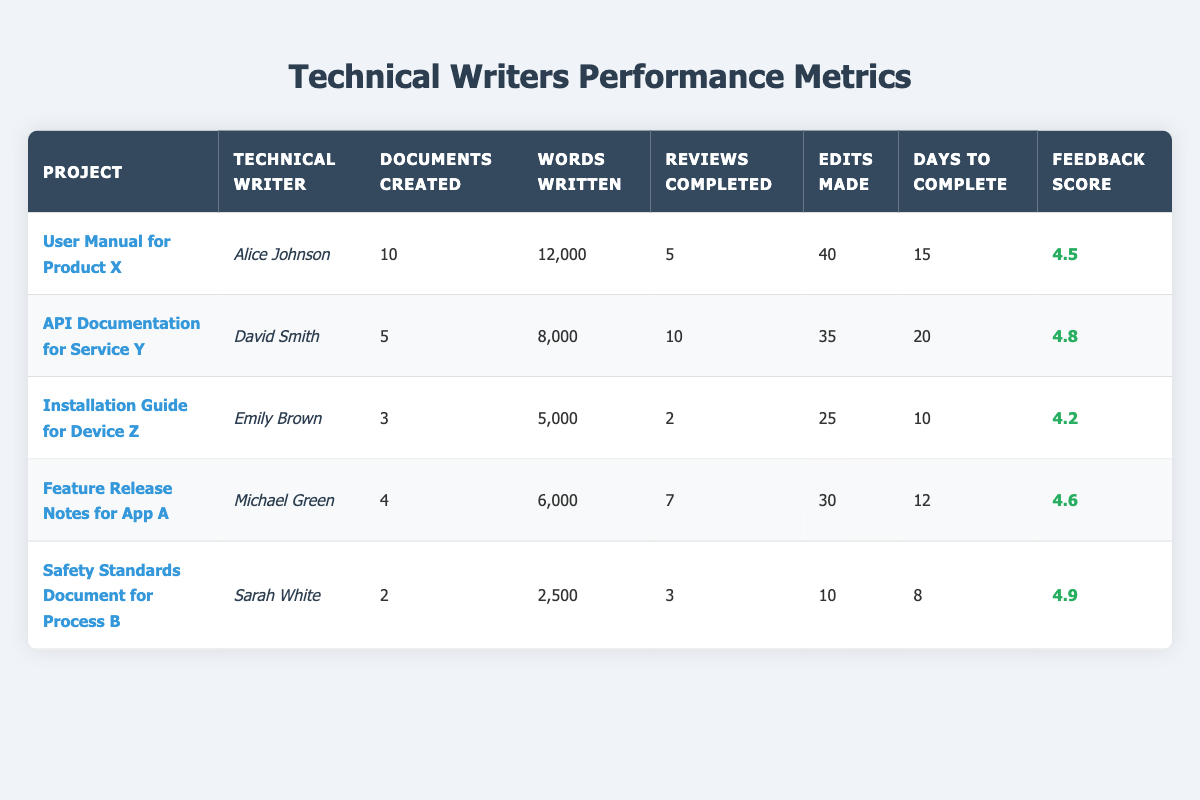What is the feedback score for Alice Johnson's project? The feedback score for Alice Johnson's project, "User Manual for Product X," can be found in the last column for that row. It is listed as 4.5.
Answer: 4.5 Which technical writer created the most documents? To determine which technical writer created the most documents, I look at the "Documents Created" column. Alice Johnson created 10 documents, which is more than any other technical writer listed.
Answer: Alice Johnson What is the total number of words written by all technical writers combined? The total number of words is calculated by summing the "Words Written" column. The numbers are: 12000 + 8000 + 5000 + 6000 + 2500 = 30500.
Answer: 30500 Did Sarah White complete more reviews than Emily Brown? I will compare the "Reviews Completed" of Sarah White and Emily Brown. Sarah White completed 3 reviews, while Emily Brown completed 2 reviews. Since 3 is greater than 2, the answer is yes.
Answer: Yes What is the average days to complete for all projects? The average days to complete can be found by adding all the values in the "Days to Complete" column and dividing by the number of projects. The sum is 15 + 20 + 10 + 12 + 8 = 65, and there are 5 projects, so the average is 65 / 5 = 13.
Answer: 13 Which technical writer had the highest feedback score? I will look at the "Feedback Score" column and identify the maximum value. Sarah White has the highest score of 4.9.
Answer: Sarah White How many documents were created in total for the projects related to devices or products? I first identify the relevant projects: "Installation Guide for Device Z" (3 documents), "User Manual for Product X" (10 documents). The sum is 3 + 10 = 13 documents created for these two projects.
Answer: 13 What is the difference in days to complete between David Smith's and Michael Green's projects? I will subtract the "Days to Complete" for Michael Green's project (12 days) from David Smith's project (20 days). The difference is 20 - 12 = 8 days.
Answer: 8 days Which project had the least number of edits made? I will look at the "Edits Made" column to find the smallest value. The project "Safety Standards Document for Process B" has the least number of edits made, which is 10.
Answer: Safety Standards Document for Process B 